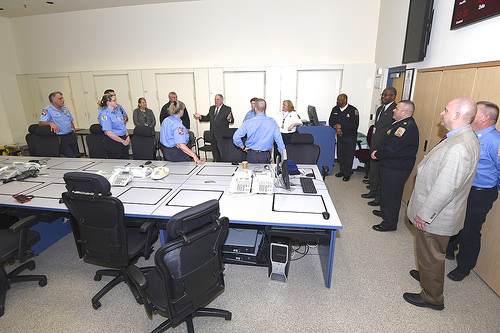<image>
Can you confirm if the women is on the table? Yes. Looking at the image, I can see the women is positioned on top of the table, with the table providing support. Is there a man on the chair? No. The man is not positioned on the chair. They may be near each other, but the man is not supported by or resting on top of the chair. Is the man on the table? No. The man is not positioned on the table. They may be near each other, but the man is not supported by or resting on top of the table. Is there a man to the right of the woman? No. The man is not to the right of the woman. The horizontal positioning shows a different relationship. Is the police in the table? No. The police is not contained within the table. These objects have a different spatial relationship. 